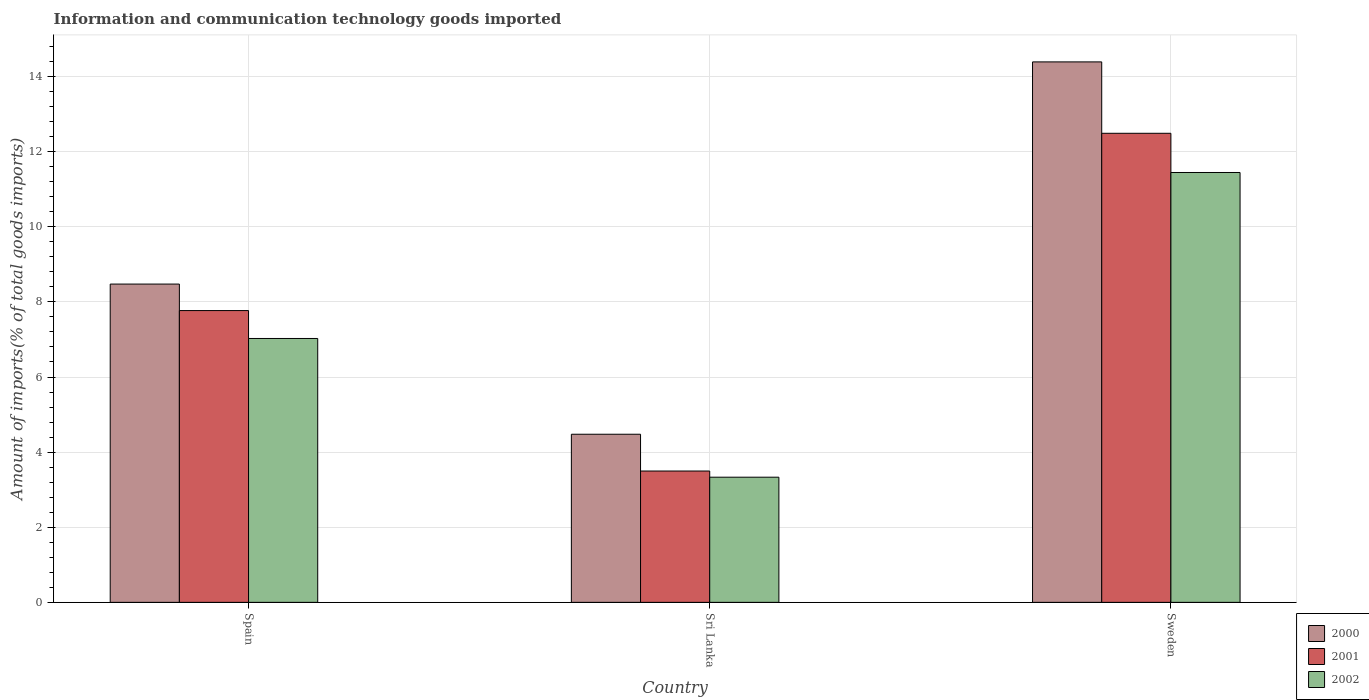Are the number of bars per tick equal to the number of legend labels?
Your answer should be very brief. Yes. Are the number of bars on each tick of the X-axis equal?
Your response must be concise. Yes. How many bars are there on the 3rd tick from the left?
Your answer should be very brief. 3. What is the label of the 2nd group of bars from the left?
Offer a terse response. Sri Lanka. In how many cases, is the number of bars for a given country not equal to the number of legend labels?
Provide a succinct answer. 0. What is the amount of goods imported in 2002 in Sweden?
Ensure brevity in your answer.  11.45. Across all countries, what is the maximum amount of goods imported in 2002?
Offer a very short reply. 11.45. Across all countries, what is the minimum amount of goods imported in 2001?
Your answer should be very brief. 3.5. In which country was the amount of goods imported in 2001 maximum?
Make the answer very short. Sweden. In which country was the amount of goods imported in 2001 minimum?
Provide a short and direct response. Sri Lanka. What is the total amount of goods imported in 2001 in the graph?
Give a very brief answer. 23.75. What is the difference between the amount of goods imported in 2001 in Spain and that in Sri Lanka?
Offer a terse response. 4.27. What is the difference between the amount of goods imported in 2002 in Sweden and the amount of goods imported in 2001 in Sri Lanka?
Keep it short and to the point. 7.95. What is the average amount of goods imported in 2002 per country?
Make the answer very short. 7.27. What is the difference between the amount of goods imported of/in 2002 and amount of goods imported of/in 2001 in Sweden?
Provide a succinct answer. -1.04. In how many countries, is the amount of goods imported in 2000 greater than 11.6 %?
Make the answer very short. 1. What is the ratio of the amount of goods imported in 2000 in Spain to that in Sweden?
Provide a succinct answer. 0.59. Is the amount of goods imported in 2002 in Spain less than that in Sweden?
Keep it short and to the point. Yes. What is the difference between the highest and the second highest amount of goods imported in 2000?
Make the answer very short. 4. What is the difference between the highest and the lowest amount of goods imported in 2002?
Keep it short and to the point. 8.11. Is it the case that in every country, the sum of the amount of goods imported in 2000 and amount of goods imported in 2001 is greater than the amount of goods imported in 2002?
Provide a short and direct response. Yes. How many bars are there?
Offer a very short reply. 9. Are all the bars in the graph horizontal?
Make the answer very short. No. How many countries are there in the graph?
Give a very brief answer. 3. Where does the legend appear in the graph?
Provide a succinct answer. Bottom right. How are the legend labels stacked?
Your answer should be compact. Vertical. What is the title of the graph?
Give a very brief answer. Information and communication technology goods imported. Does "2012" appear as one of the legend labels in the graph?
Provide a succinct answer. No. What is the label or title of the Y-axis?
Your response must be concise. Amount of imports(% of total goods imports). What is the Amount of imports(% of total goods imports) in 2000 in Spain?
Keep it short and to the point. 8.47. What is the Amount of imports(% of total goods imports) of 2001 in Spain?
Your answer should be compact. 7.77. What is the Amount of imports(% of total goods imports) of 2002 in Spain?
Keep it short and to the point. 7.03. What is the Amount of imports(% of total goods imports) in 2000 in Sri Lanka?
Ensure brevity in your answer.  4.48. What is the Amount of imports(% of total goods imports) of 2001 in Sri Lanka?
Keep it short and to the point. 3.5. What is the Amount of imports(% of total goods imports) of 2002 in Sri Lanka?
Offer a very short reply. 3.33. What is the Amount of imports(% of total goods imports) of 2000 in Sweden?
Offer a very short reply. 14.39. What is the Amount of imports(% of total goods imports) of 2001 in Sweden?
Your response must be concise. 12.49. What is the Amount of imports(% of total goods imports) in 2002 in Sweden?
Ensure brevity in your answer.  11.45. Across all countries, what is the maximum Amount of imports(% of total goods imports) of 2000?
Provide a succinct answer. 14.39. Across all countries, what is the maximum Amount of imports(% of total goods imports) in 2001?
Offer a terse response. 12.49. Across all countries, what is the maximum Amount of imports(% of total goods imports) in 2002?
Keep it short and to the point. 11.45. Across all countries, what is the minimum Amount of imports(% of total goods imports) of 2000?
Your response must be concise. 4.48. Across all countries, what is the minimum Amount of imports(% of total goods imports) in 2001?
Give a very brief answer. 3.5. Across all countries, what is the minimum Amount of imports(% of total goods imports) in 2002?
Your answer should be compact. 3.33. What is the total Amount of imports(% of total goods imports) in 2000 in the graph?
Your answer should be very brief. 27.34. What is the total Amount of imports(% of total goods imports) of 2001 in the graph?
Provide a short and direct response. 23.75. What is the total Amount of imports(% of total goods imports) in 2002 in the graph?
Offer a very short reply. 21.8. What is the difference between the Amount of imports(% of total goods imports) of 2000 in Spain and that in Sri Lanka?
Keep it short and to the point. 4. What is the difference between the Amount of imports(% of total goods imports) of 2001 in Spain and that in Sri Lanka?
Offer a very short reply. 4.27. What is the difference between the Amount of imports(% of total goods imports) in 2002 in Spain and that in Sri Lanka?
Your answer should be compact. 3.69. What is the difference between the Amount of imports(% of total goods imports) of 2000 in Spain and that in Sweden?
Make the answer very short. -5.92. What is the difference between the Amount of imports(% of total goods imports) of 2001 in Spain and that in Sweden?
Keep it short and to the point. -4.72. What is the difference between the Amount of imports(% of total goods imports) of 2002 in Spain and that in Sweden?
Provide a short and direct response. -4.42. What is the difference between the Amount of imports(% of total goods imports) in 2000 in Sri Lanka and that in Sweden?
Give a very brief answer. -9.91. What is the difference between the Amount of imports(% of total goods imports) in 2001 in Sri Lanka and that in Sweden?
Give a very brief answer. -8.99. What is the difference between the Amount of imports(% of total goods imports) of 2002 in Sri Lanka and that in Sweden?
Offer a terse response. -8.11. What is the difference between the Amount of imports(% of total goods imports) in 2000 in Spain and the Amount of imports(% of total goods imports) in 2001 in Sri Lanka?
Keep it short and to the point. 4.98. What is the difference between the Amount of imports(% of total goods imports) in 2000 in Spain and the Amount of imports(% of total goods imports) in 2002 in Sri Lanka?
Provide a succinct answer. 5.14. What is the difference between the Amount of imports(% of total goods imports) of 2001 in Spain and the Amount of imports(% of total goods imports) of 2002 in Sri Lanka?
Offer a very short reply. 4.44. What is the difference between the Amount of imports(% of total goods imports) in 2000 in Spain and the Amount of imports(% of total goods imports) in 2001 in Sweden?
Offer a terse response. -4.01. What is the difference between the Amount of imports(% of total goods imports) of 2000 in Spain and the Amount of imports(% of total goods imports) of 2002 in Sweden?
Keep it short and to the point. -2.97. What is the difference between the Amount of imports(% of total goods imports) of 2001 in Spain and the Amount of imports(% of total goods imports) of 2002 in Sweden?
Your response must be concise. -3.68. What is the difference between the Amount of imports(% of total goods imports) in 2000 in Sri Lanka and the Amount of imports(% of total goods imports) in 2001 in Sweden?
Provide a short and direct response. -8.01. What is the difference between the Amount of imports(% of total goods imports) of 2000 in Sri Lanka and the Amount of imports(% of total goods imports) of 2002 in Sweden?
Ensure brevity in your answer.  -6.97. What is the difference between the Amount of imports(% of total goods imports) in 2001 in Sri Lanka and the Amount of imports(% of total goods imports) in 2002 in Sweden?
Make the answer very short. -7.95. What is the average Amount of imports(% of total goods imports) in 2000 per country?
Your answer should be compact. 9.11. What is the average Amount of imports(% of total goods imports) in 2001 per country?
Your response must be concise. 7.92. What is the average Amount of imports(% of total goods imports) in 2002 per country?
Provide a succinct answer. 7.27. What is the difference between the Amount of imports(% of total goods imports) in 2000 and Amount of imports(% of total goods imports) in 2001 in Spain?
Your response must be concise. 0.71. What is the difference between the Amount of imports(% of total goods imports) of 2000 and Amount of imports(% of total goods imports) of 2002 in Spain?
Offer a terse response. 1.45. What is the difference between the Amount of imports(% of total goods imports) in 2001 and Amount of imports(% of total goods imports) in 2002 in Spain?
Give a very brief answer. 0.74. What is the difference between the Amount of imports(% of total goods imports) of 2000 and Amount of imports(% of total goods imports) of 2001 in Sri Lanka?
Your response must be concise. 0.98. What is the difference between the Amount of imports(% of total goods imports) in 2000 and Amount of imports(% of total goods imports) in 2002 in Sri Lanka?
Ensure brevity in your answer.  1.14. What is the difference between the Amount of imports(% of total goods imports) of 2001 and Amount of imports(% of total goods imports) of 2002 in Sri Lanka?
Offer a terse response. 0.16. What is the difference between the Amount of imports(% of total goods imports) of 2000 and Amount of imports(% of total goods imports) of 2001 in Sweden?
Keep it short and to the point. 1.9. What is the difference between the Amount of imports(% of total goods imports) of 2000 and Amount of imports(% of total goods imports) of 2002 in Sweden?
Your response must be concise. 2.94. What is the difference between the Amount of imports(% of total goods imports) in 2001 and Amount of imports(% of total goods imports) in 2002 in Sweden?
Provide a short and direct response. 1.04. What is the ratio of the Amount of imports(% of total goods imports) in 2000 in Spain to that in Sri Lanka?
Your response must be concise. 1.89. What is the ratio of the Amount of imports(% of total goods imports) of 2001 in Spain to that in Sri Lanka?
Your answer should be compact. 2.22. What is the ratio of the Amount of imports(% of total goods imports) of 2002 in Spain to that in Sri Lanka?
Provide a short and direct response. 2.11. What is the ratio of the Amount of imports(% of total goods imports) in 2000 in Spain to that in Sweden?
Your answer should be compact. 0.59. What is the ratio of the Amount of imports(% of total goods imports) in 2001 in Spain to that in Sweden?
Keep it short and to the point. 0.62. What is the ratio of the Amount of imports(% of total goods imports) of 2002 in Spain to that in Sweden?
Offer a terse response. 0.61. What is the ratio of the Amount of imports(% of total goods imports) of 2000 in Sri Lanka to that in Sweden?
Your response must be concise. 0.31. What is the ratio of the Amount of imports(% of total goods imports) of 2001 in Sri Lanka to that in Sweden?
Ensure brevity in your answer.  0.28. What is the ratio of the Amount of imports(% of total goods imports) of 2002 in Sri Lanka to that in Sweden?
Ensure brevity in your answer.  0.29. What is the difference between the highest and the second highest Amount of imports(% of total goods imports) in 2000?
Make the answer very short. 5.92. What is the difference between the highest and the second highest Amount of imports(% of total goods imports) in 2001?
Offer a terse response. 4.72. What is the difference between the highest and the second highest Amount of imports(% of total goods imports) of 2002?
Your answer should be very brief. 4.42. What is the difference between the highest and the lowest Amount of imports(% of total goods imports) in 2000?
Your answer should be compact. 9.91. What is the difference between the highest and the lowest Amount of imports(% of total goods imports) in 2001?
Keep it short and to the point. 8.99. What is the difference between the highest and the lowest Amount of imports(% of total goods imports) in 2002?
Your response must be concise. 8.11. 